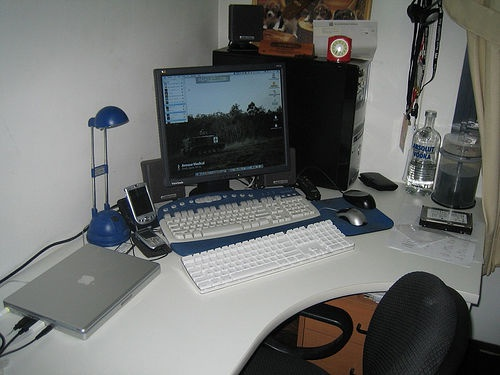Describe the objects in this image and their specific colors. I can see tv in gray and black tones, chair in gray, black, and maroon tones, laptop in gray tones, keyboard in gray, darkgray, and lightgray tones, and keyboard in gray, darkgray, black, and navy tones in this image. 